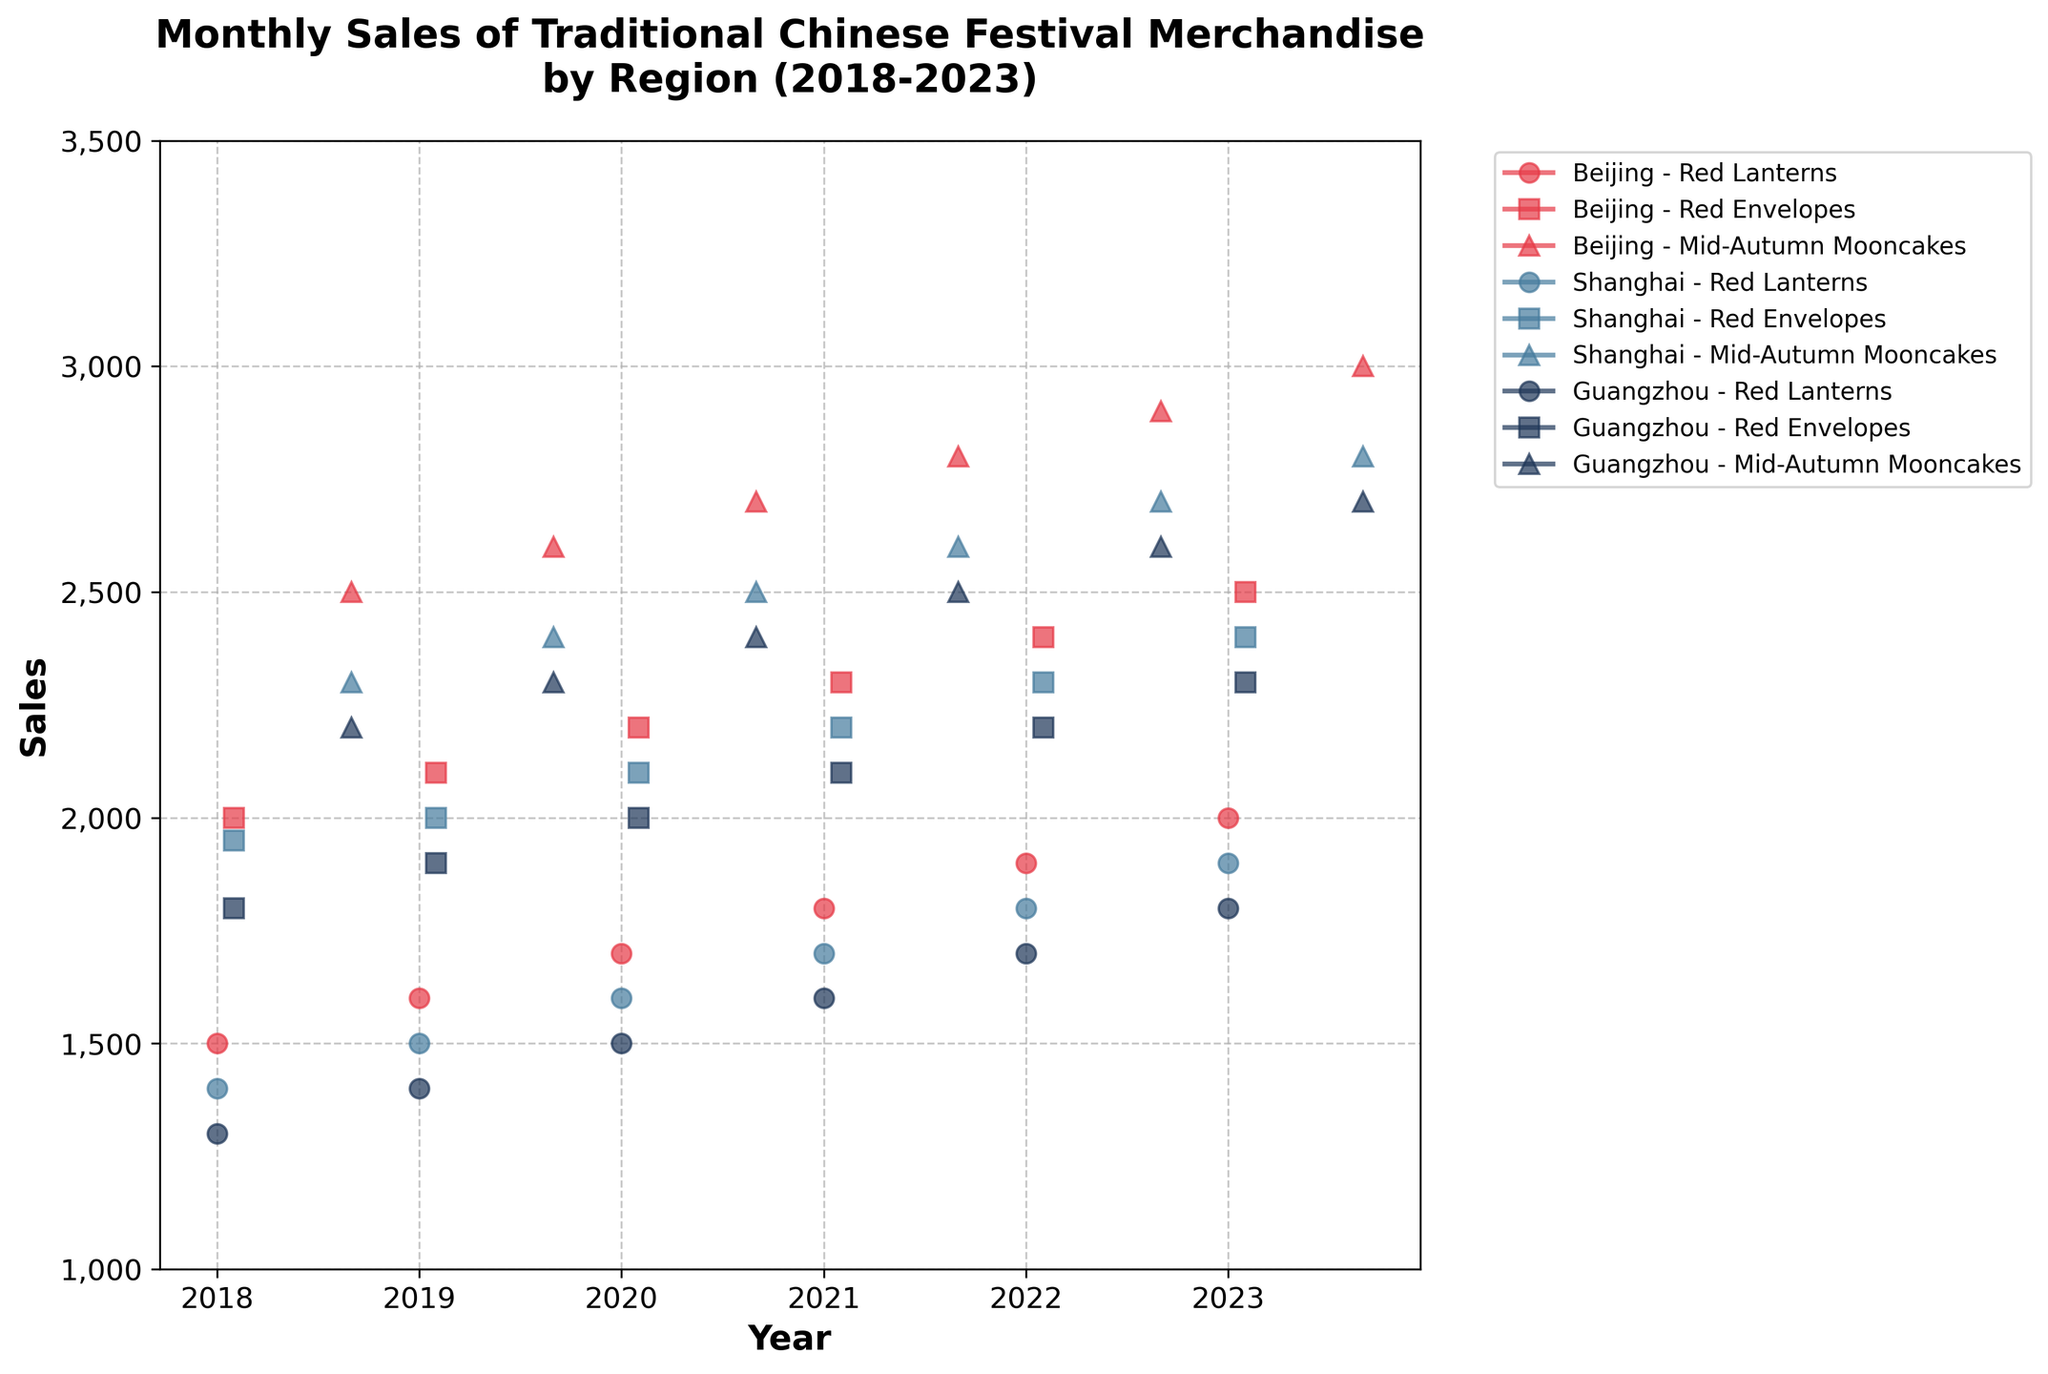What are the available regions in the plot? The regions are labeled in the legend of the plot, showing different colors for each region: Beijing, Shanghai, and Guangzhou.
Answer: Beijing, Shanghai, Guangzhou Which merchandise had the highest sales in Beijing in January 2023? In the plot, the sales of different merchandise are marked with different shapes. The highest sales value for Beijing in January 2023 can be identified by following the color and marker for Red Lanterns, which peak in January 2023.
Answer: Red Lanterns How did the sales of red envelopes in Guangzhou change from 2019 to 2023? Follow the series for Guangzhou with the marker for Red Envelopes over the years and observe the trend: in 2019 sales were 1900, and in 2023 they increased to 2300, which shows a noticeable rise.
Answer: Increased Which region saw the highest sales of Mid-Autumn Mooncakes in 2020? Identify the series for 2020 and compare the sales of Mid-Autumn Mooncakes marked with the same shape across different colors. Beijing had the highest sales at 2700.
Answer: Beijing What was the trend in sales for red lanterns in Shanghai from 2018 to 2023? By observing the sales point markers for Shanghai's red lanterns each year from 2018 to 2023, you will see a consistent increase in sales from 1400 in 2018 to 1900 in 2023.
Answer: Increasing Compare the trend of Mid-Autumn Mooncakes sales in all regions over the five years. Identify the series for Mid-Autumn Mooncakes for Beijing, Shanghai, and Guangzhou and track the values for each year. In all regions, the sales increased yearly, with sales highest in Beijing, followed by Shanghai, then Guangzhou.
Answer: All regions have increasing trends, Beijing is highest Which merchandise in which region had a dramatic change in sales during the analysis period? By observing the plot over the years for all merchandise and regions, the Red Envelopes in Beijing show a significant rise from 2000 in 2018 to 2500 in 2023.
Answer: Red Envelopes in Beijing What is the average sales of Red Lanterns in Beijing over the five years? To find the average, sum the values of Red Lanterns sales in Beijing for each year: 1500, 1600, 1700, 1800, 1900, 2000. Total = 10500, divided by 6 years: 10500/6 = 1750.
Answer: 1750 How many different types of merchandise are depicted in the plot? The legend in the plot lists all types of merchandise represented by distinct markers: Red Lanterns, Red Envelopes, and Mid-Autumn Mooncakes.
Answer: 3 types What month and year did Shanghai experience its peak sales for Mid-Autumn Mooncakes? Follow the line for Mid-Autumn Mooncakes sales in Shanghai and identify the peak value, which occurs in September 2023.
Answer: September 2023 